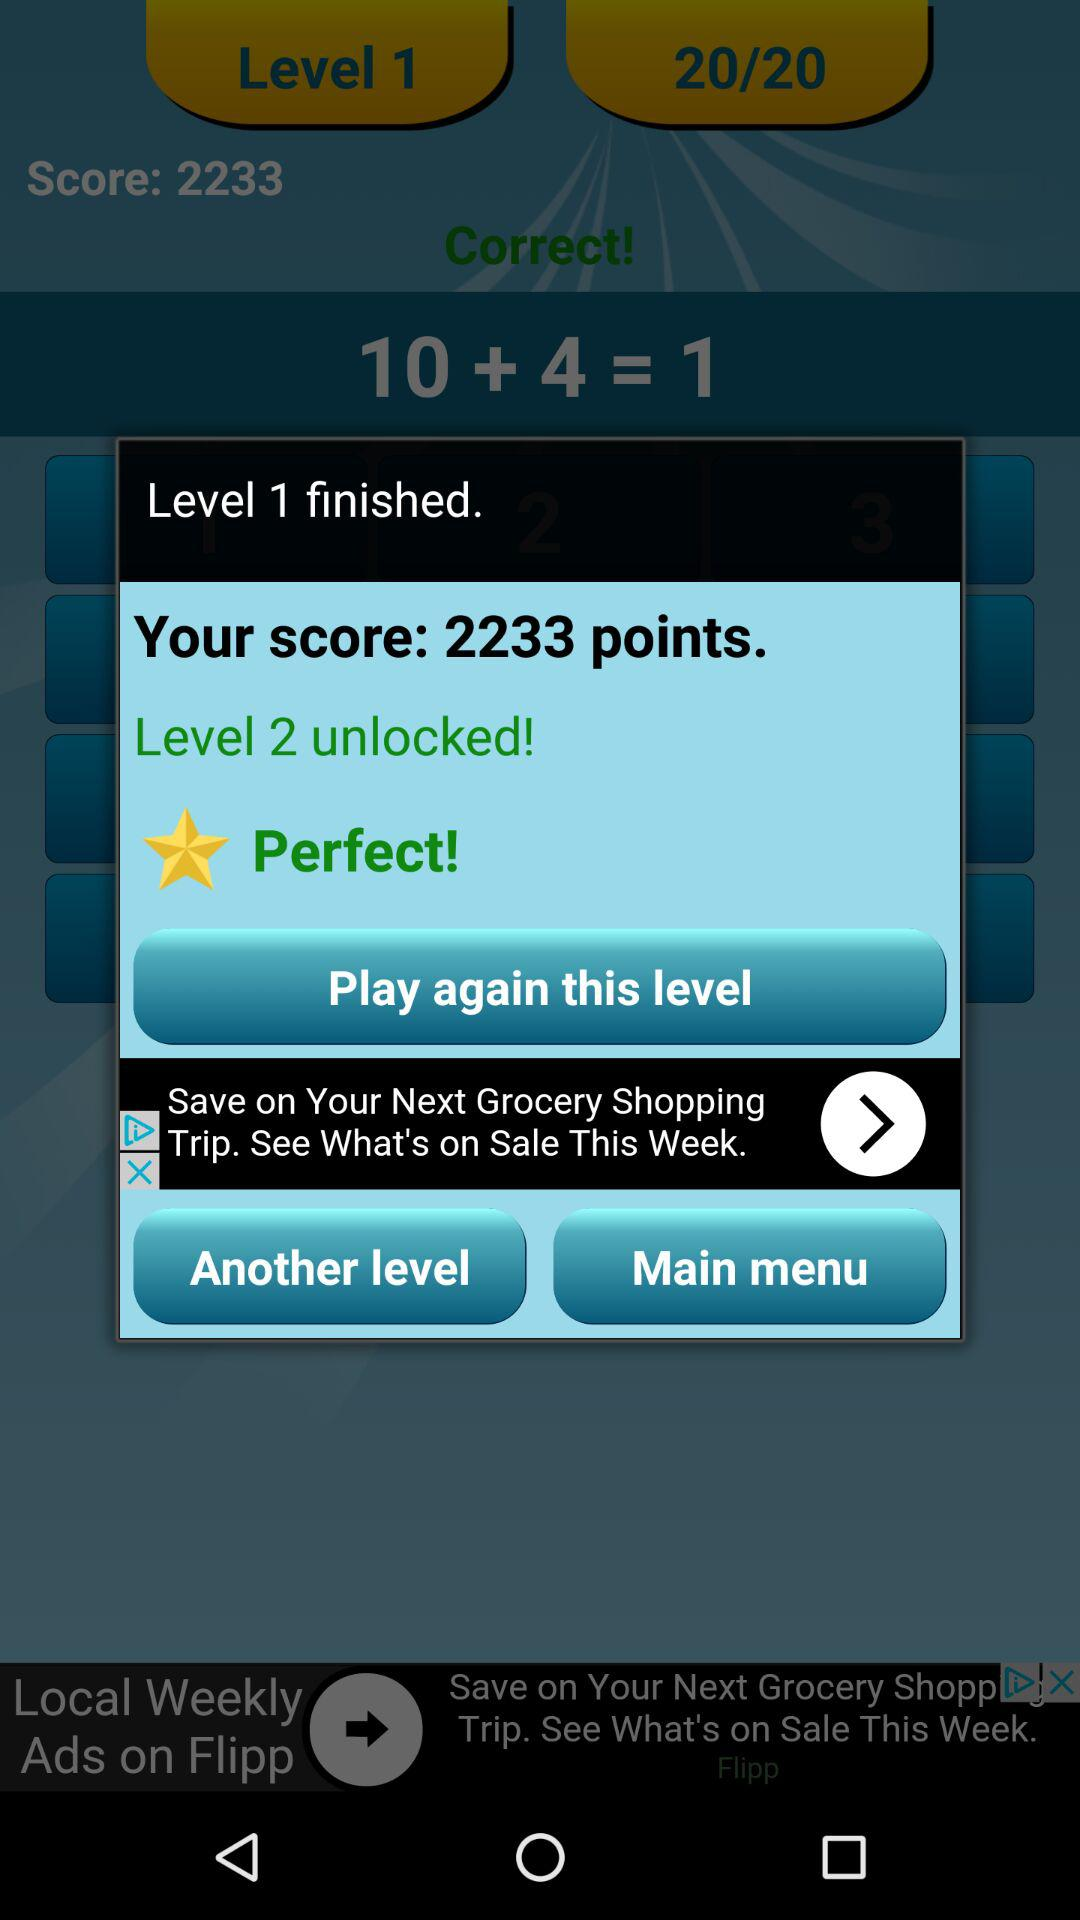What level is unlocked? The unlocked level is 2. 